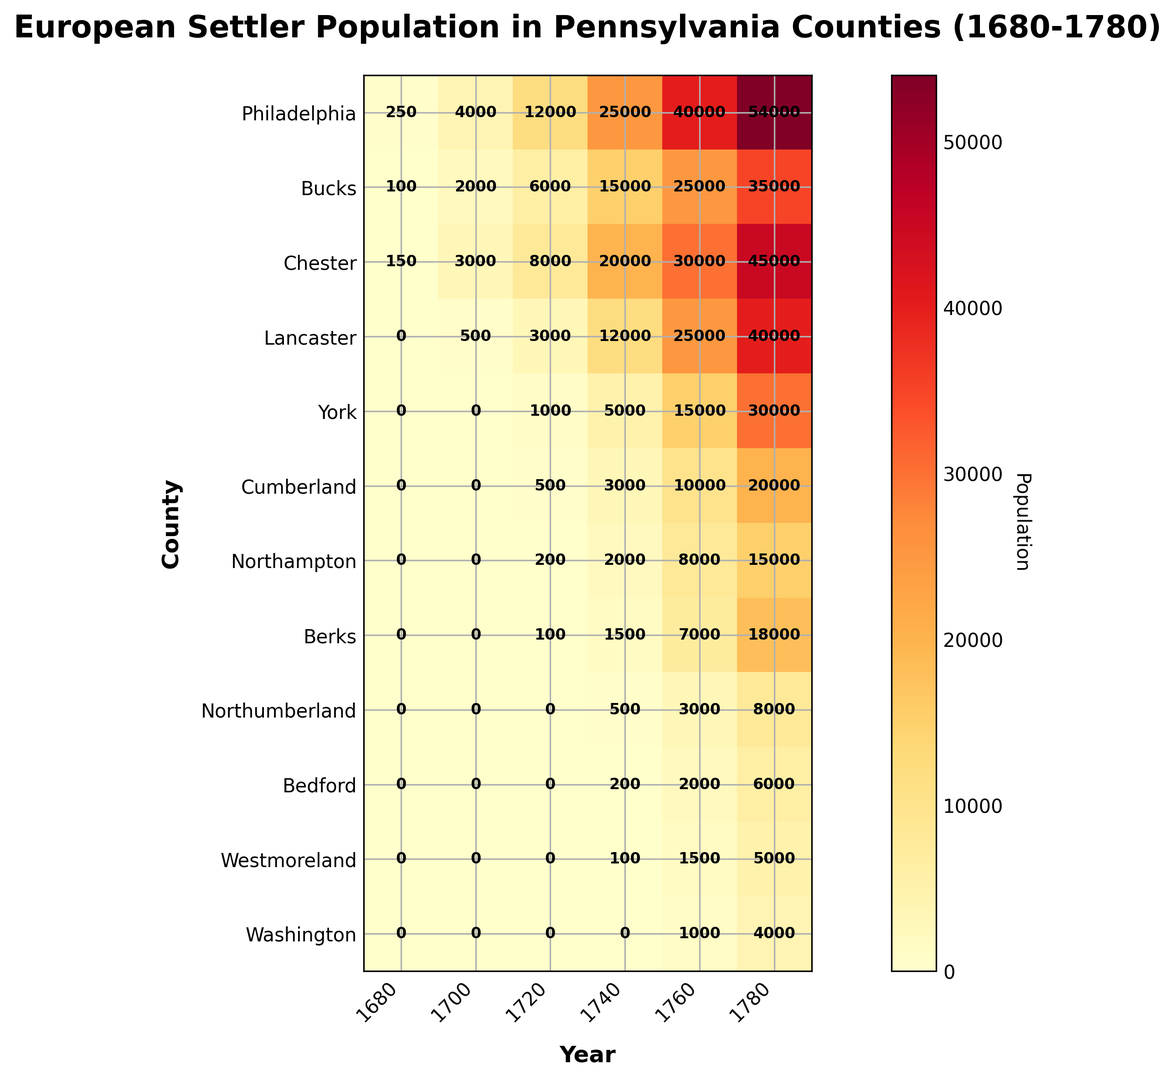What is the overall trend in Philadelphia county from 1680 to 1780? Refer to the figure, observe that the population numbers for Philadelphia county are increasing over each time period: 250 in 1680, 4000 in 1700, 12000 in 1720, 25000 in 1740, 40000 in 1760, and 54000 in 1780. This indicates a steady upward trend.
Answer: Increasing By how much did the population of Chester county grow between 1700 and 1760? In the figure, for Chester county in 1700, the population is 3000. In 1760, the population is 30000. The difference between these two values is 30000 - 3000 = 27000.
Answer: 27000 Which county had the smallest population in 1780? Refer to the last column (1780), and find that Washington has the smallest population with a value of 4000.
Answer: Washington What is the overall pattern of color from 1680 through 1780 across all counties? Observing the heatmap, the color intensifies (becomes more red) as we move from left (1680) to right (1780), indicating increasing population densities for most counties as time progresses.
Answer: Increasing in intensity Which year shows the most varied population numbers among the counties? Look closely across each year to judge the variation. The year 1780 shows a wide range in values (from 4000 in Washington to 54000 in Philadelphia), suggesting that year had the most varied population numbers.
Answer: 1780 Which county had the highest population in 1740 and by how much? For the year 1740, compare the populations of all counties. Philadelphia had the highest population with 25000. This is higher than any other county for that year.
Answer: Philadelphia, 25000 Compare the population of Lancaster and Bucks County in 1700. Which had more settlers, and by how much? In 1700, Bucks had a population of 2000, while Lancaster had a population of 500. The difference is 2000 - 500 = 1500. Thus, Bucks had 1500 more settlers than Lancaster.
Answer: Bucks by 1500 What was the population growth in Northampton county from 1720 to 1780? Northampton's population was 200 in 1720 and increased to 15000 by 1780. The growth is 15000 - 200 = 14800.
Answer: 14800 Which three counties had no population in 1680? Referring to the first column (1680), York, Cumberland, and Lancaster all had zero population.
Answer: York, Cumberland, Lancaster 